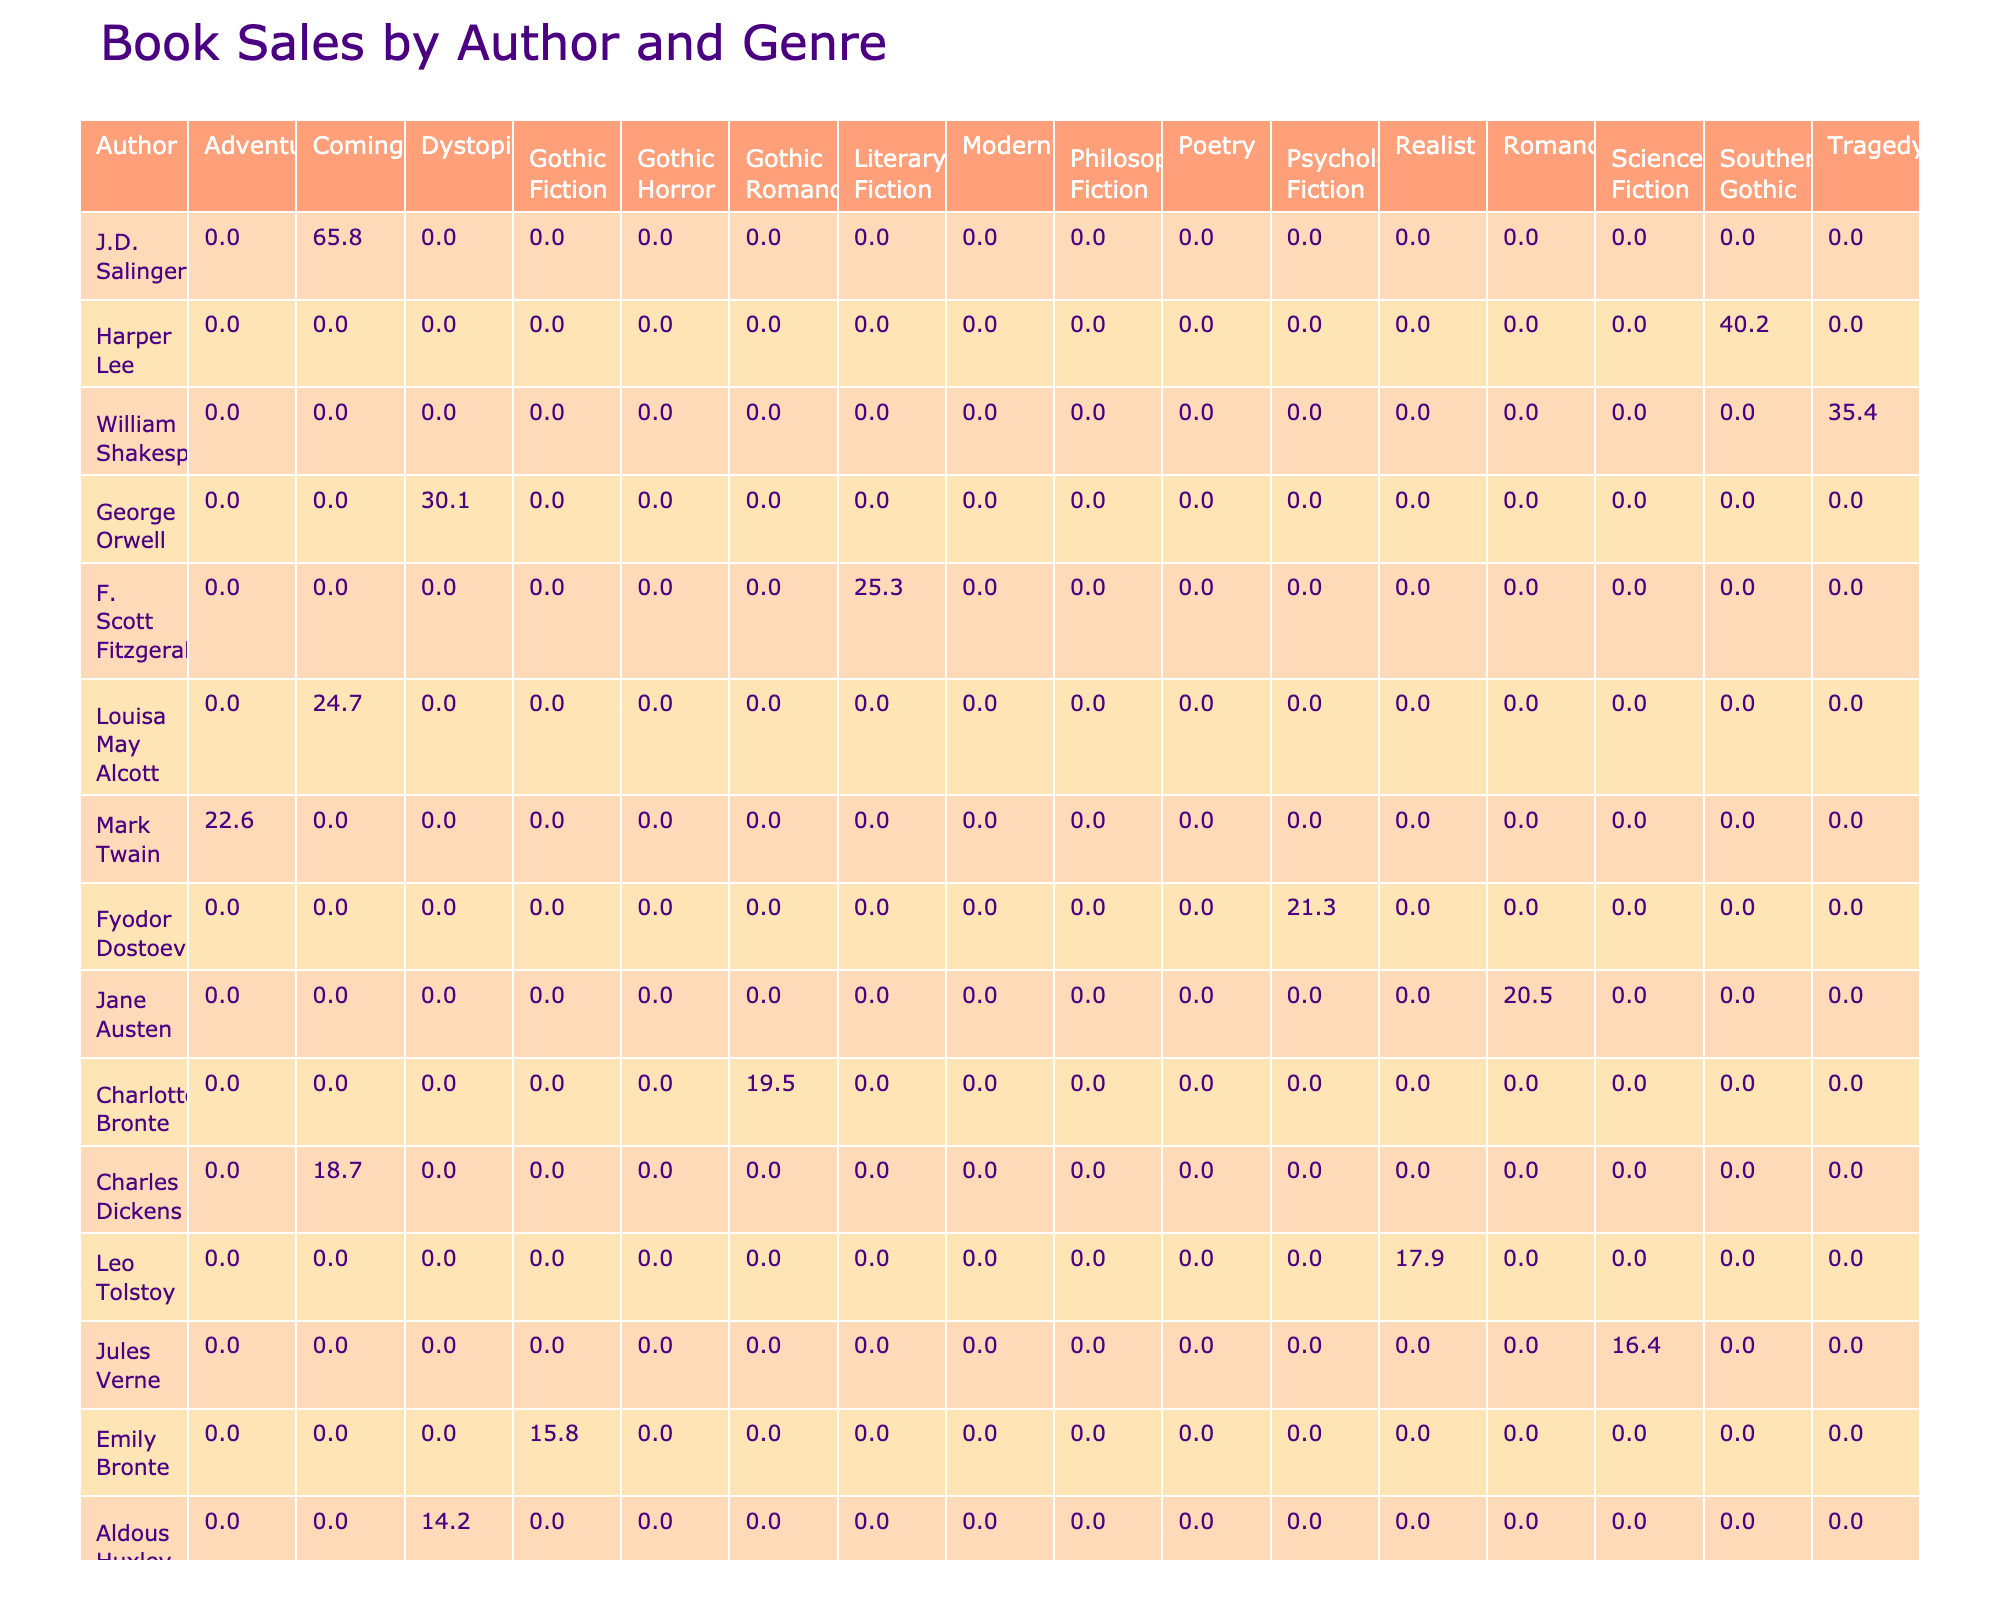What is the total sales of J.D. Salinger? Looking at the sales data for J.D. Salinger, the table indicates his book "The Catcher in the Rye" has sales of 65.8 million. Therefore, the total sales for this author is 65.8 million.
Answer: 65.8 million Which author has the highest sales in the Dystopian genre? The table shows that George Orwell's "1984" has sales of 30.1 million, and Aldous Huxley's "Brave New World" has 14.2 million. Hence, George Orwell has the highest sales in the Dystopian genre.
Answer: George Orwell What is the combined sales of all books in the Gothic Fiction genre? The Gothic Fiction genre includes "Wuthering Heights" by Emily Bronte (15.8 million) and "Jane Eyre" by Charlotte Bronte (19.5 million). Adding these together gives 15.8 + 19.5 = 35.3 million.
Answer: 35.3 million Is there any author with sales of more than 40 million? By examining the sales figures, Harper Lee's "To Kill a Mockingbird" has sales of 40.2 million, and J.D. Salinger's sales are more than 40 million, which definitely confirms that there is an author with such sales.
Answer: Yes Which genre has the highest total sales, and what is the amount? To find the genre with the highest total sales, we need to sum the sales for each genre. Calculating shows: Romance (20.5 million), Coming-of-age (18.7 + 65.8 + 24.7 = 109.2 million), Literary Fiction (25.3 + 11.8 = 37.1 million), and others yield lower figures. Therefore, Coming-of-age has the highest sales with 109.2 million.
Answer: Coming-of-age, 109.2 million 